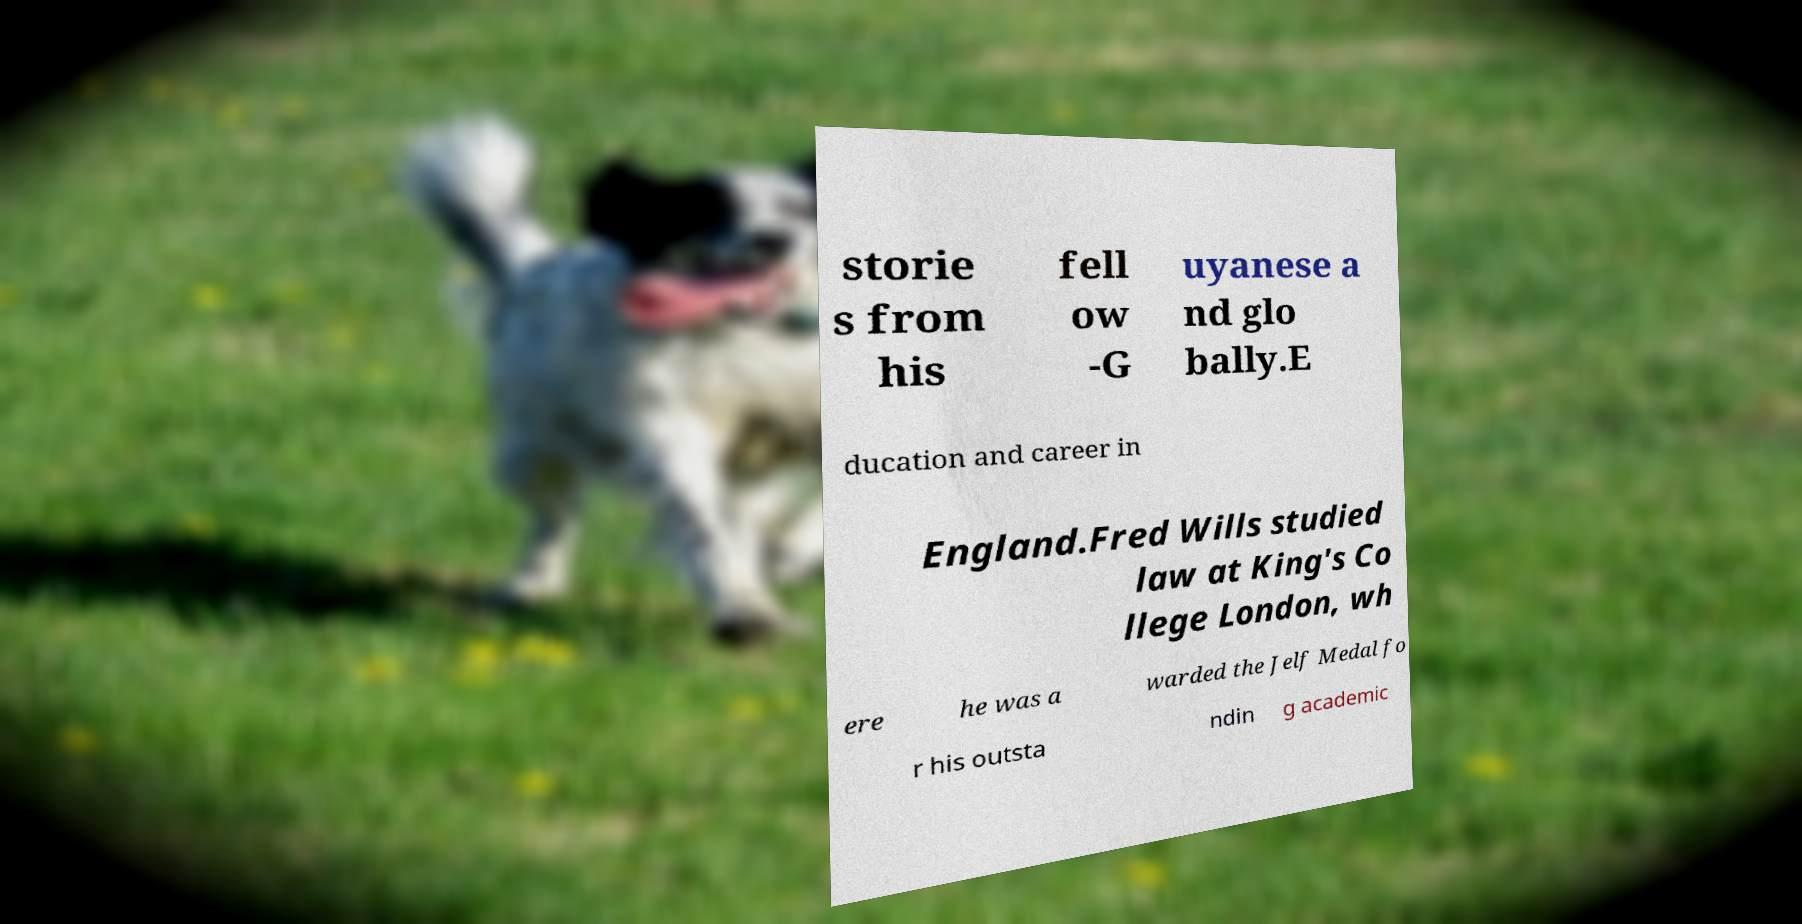There's text embedded in this image that I need extracted. Can you transcribe it verbatim? storie s from his fell ow -G uyanese a nd glo bally.E ducation and career in England.Fred Wills studied law at King's Co llege London, wh ere he was a warded the Jelf Medal fo r his outsta ndin g academic 